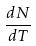<formula> <loc_0><loc_0><loc_500><loc_500>\frac { d N } { d T }</formula> 